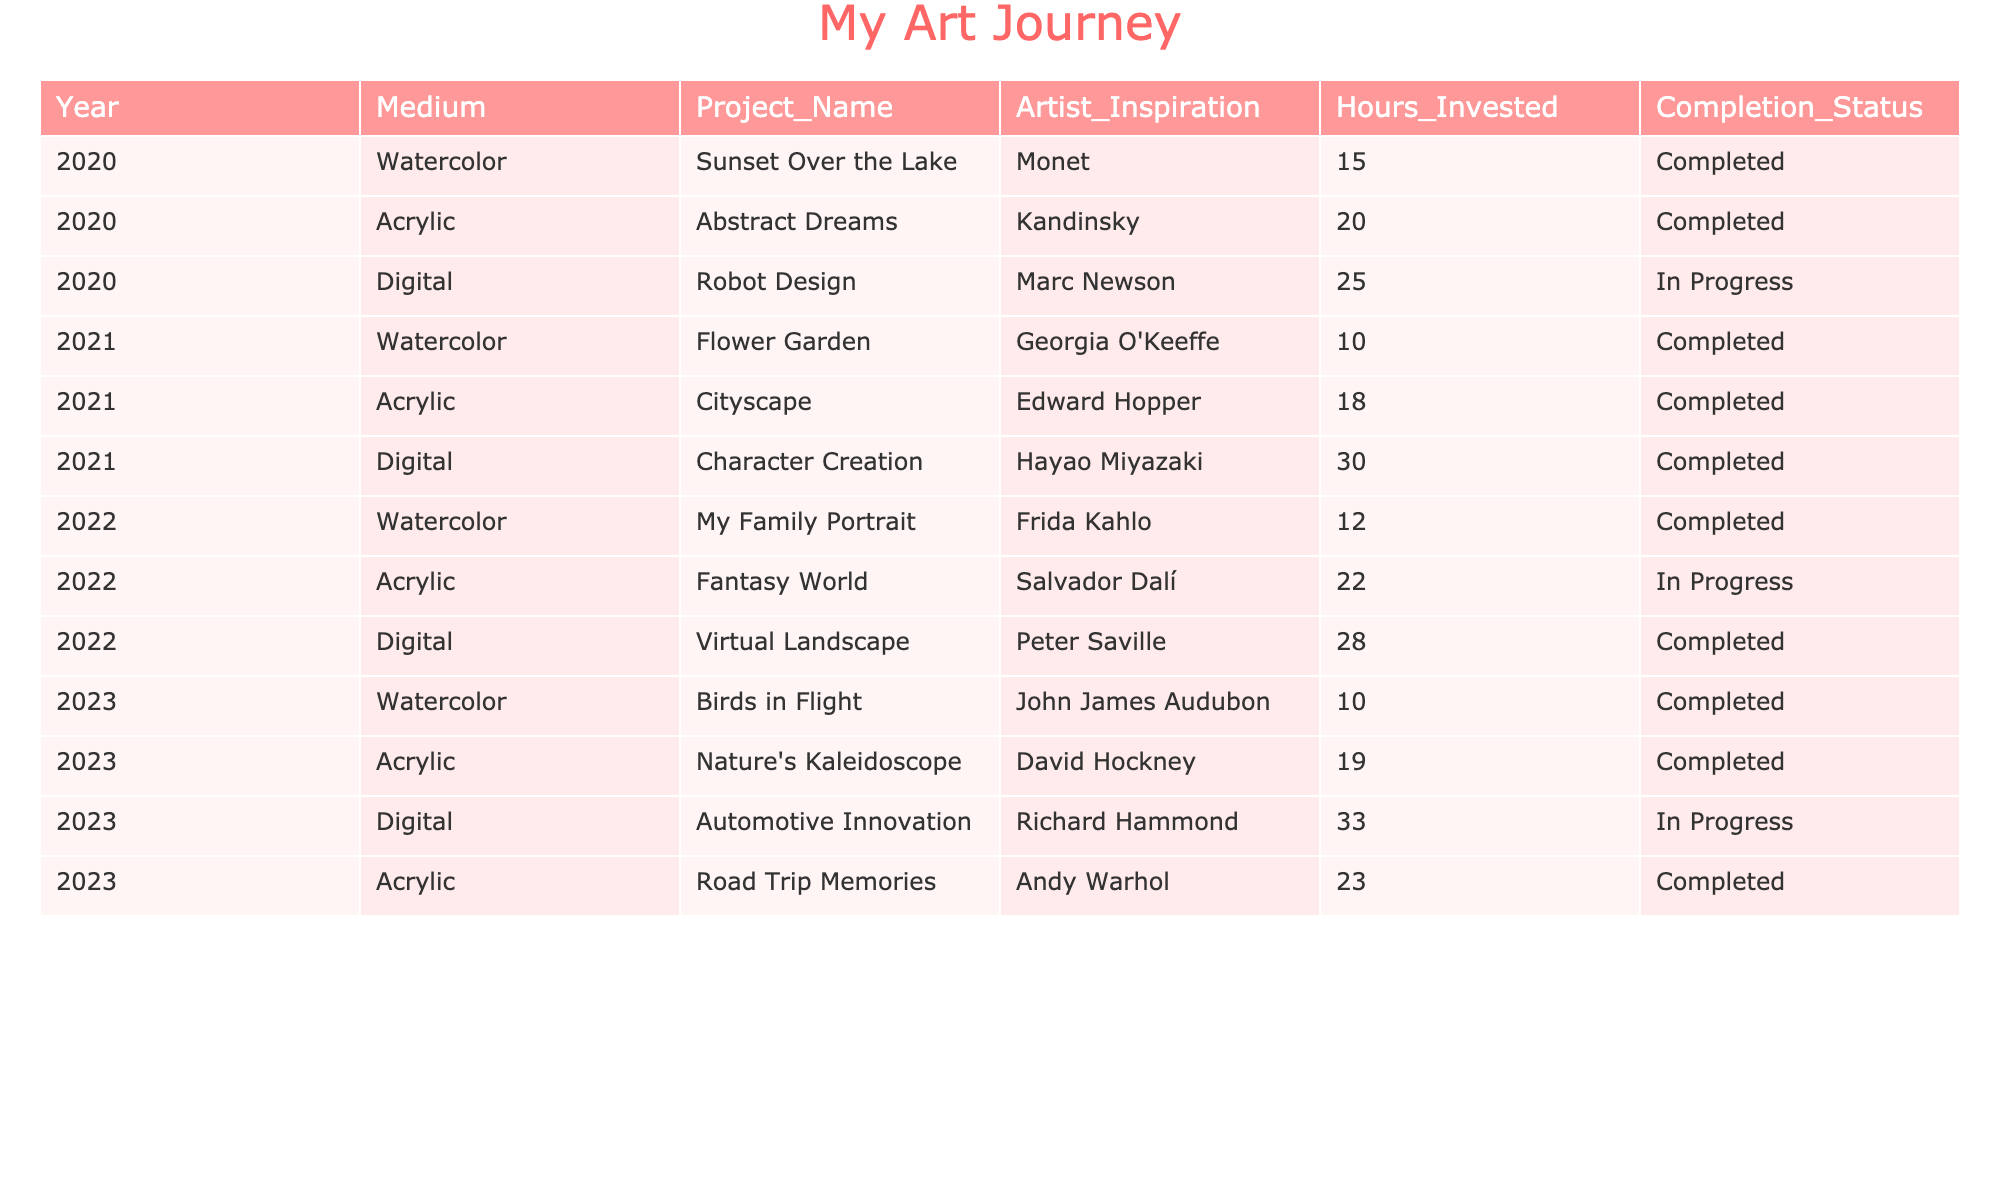What is the total number of projects completed in 2020? In 2020, there are three projects listed. Two of them, "Sunset Over the Lake" and "Abstract Dreams," are marked as completed. The "Robot Design" project is still in progress. Therefore, the total number of completed projects in 2020 is 2.
Answer: 2 Which medium had the most hours invested in the year 2023? In 2023, the hours invested for each medium are as follows: Watercolor: 10, Acrylic: 19, Digital: 33. The Digital medium has the highest hours invested.
Answer: Digital Was there any project in 2021 that was not completed? All projects listed for 2021, which are "Flower Garden," "Cityscape," and "Character Creation," have a completion status of Completed. Therefore, there were no projects in 2021 that were not completed.
Answer: No How many projects in total were completed across all years? To find the total completed projects, we need to look at each year and count the completed status: 2020: 2, 2021: 3, 2022: 2, and 2023: 3. Summing these gives us 2 + 3 + 2 + 3 = 10.
Answer: 10 What was the average number of hours invested in projects that utilized the Acrylic medium? The Acrylic projects and their hours are: 20 (2020), 18 (2021), 22 (2022), 19 (2023), and 23 (2023). Summing these gives 20 + 18 + 22 + 19 + 23 = 102, and there are 5 projects. The average is 102 / 5 = 20.4.
Answer: 20.4 Which artist was the inspiration for the project "Virtual Landscape"? The project "Virtual Landscape," completed in 2022, was inspired by the artist Peter Saville.
Answer: Peter Saville In which year was the highest number of hours invested in projects overall? We can calculate total hours for each year: 2020: 15 + 20 + 25 = 60, 2021: 10 + 18 + 30 = 58, 2022: 12 + 22 + 28 = 62, and 2023: 10 + 19 + 33 + 23 = 85. The year 2023 has the highest total at 85 hours.
Answer: 2023 Were there any projects that incorporated both Watercolor and Acrylic mediums? The projects listed do not indicate any that utilized both Watercolor and Acrylic mediums together; each project is associated with only one medium.
Answer: No What is the status of the "Character Creation" project? The "Character Creation" project from 2021 is marked as completed.
Answer: Completed How many projects used the Digital medium in 2022, and what was their completion status? In 2022, there was one Digital project titled "Virtual Landscape," and it was completed.
Answer: 1 completed 